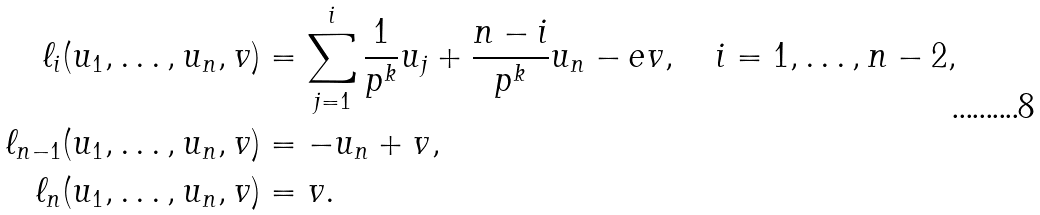<formula> <loc_0><loc_0><loc_500><loc_500>\ell _ { i } ( u _ { 1 } , \dots , u _ { n } , v ) & = \sum _ { j = 1 } ^ { i } \frac { 1 } { p ^ { k } } u _ { j } + \frac { n - i } { p ^ { k } } u _ { n } - e v , \quad \text {$i=1,\dots,n-2$} , \\ \ell _ { n - 1 } ( u _ { 1 } , \dots , u _ { n } , v ) & = - u _ { n } + v , \\ \ell _ { n } ( u _ { 1 } , \dots , u _ { n } , v ) & = v .</formula> 